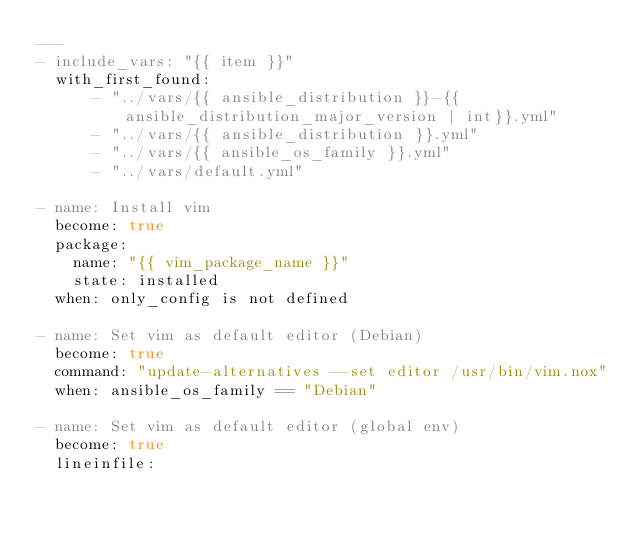Convert code to text. <code><loc_0><loc_0><loc_500><loc_500><_YAML_>---
- include_vars: "{{ item }}"
  with_first_found:
      - "../vars/{{ ansible_distribution }}-{{ ansible_distribution_major_version | int}}.yml"
      - "../vars/{{ ansible_distribution }}.yml"
      - "../vars/{{ ansible_os_family }}.yml"
      - "../vars/default.yml"

- name: Install vim
  become: true
  package:
    name: "{{ vim_package_name }}"
    state: installed
  when: only_config is not defined

- name: Set vim as default editor (Debian)
  become: true
  command: "update-alternatives --set editor /usr/bin/vim.nox"
  when: ansible_os_family == "Debian"

- name: Set vim as default editor (global env)
  become: true
  lineinfile:</code> 